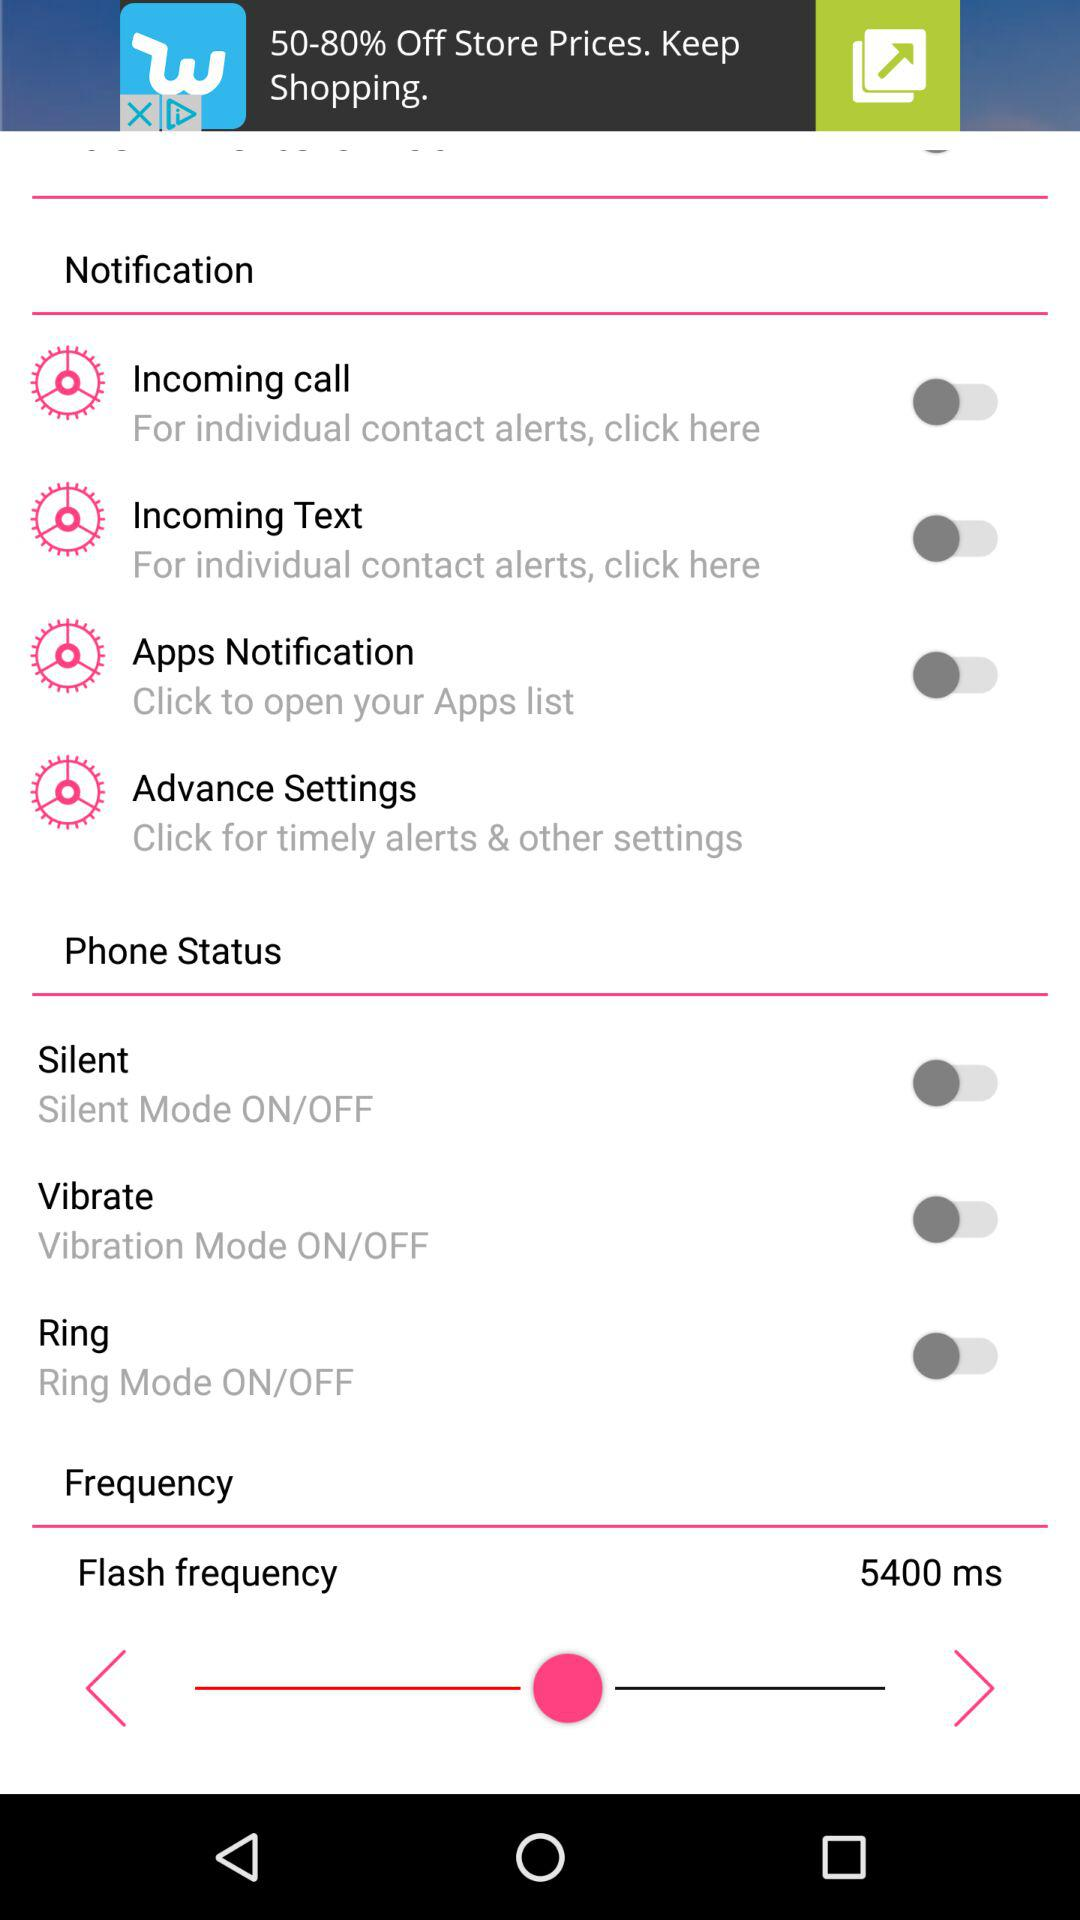Which applications are in the apps list?
When the provided information is insufficient, respond with <no answer>. <no answer> 